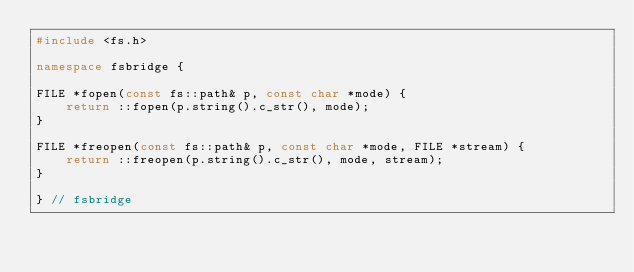<code> <loc_0><loc_0><loc_500><loc_500><_C++_>#include <fs.h>

namespace fsbridge {

FILE *fopen(const fs::path& p, const char *mode) {
    return ::fopen(p.string().c_str(), mode);
}

FILE *freopen(const fs::path& p, const char *mode, FILE *stream) {
    return ::freopen(p.string().c_str(), mode, stream);
}

} // fsbridge
</code> 